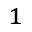Convert formula to latex. <formula><loc_0><loc_0><loc_500><loc_500>^ { 1 }</formula> 